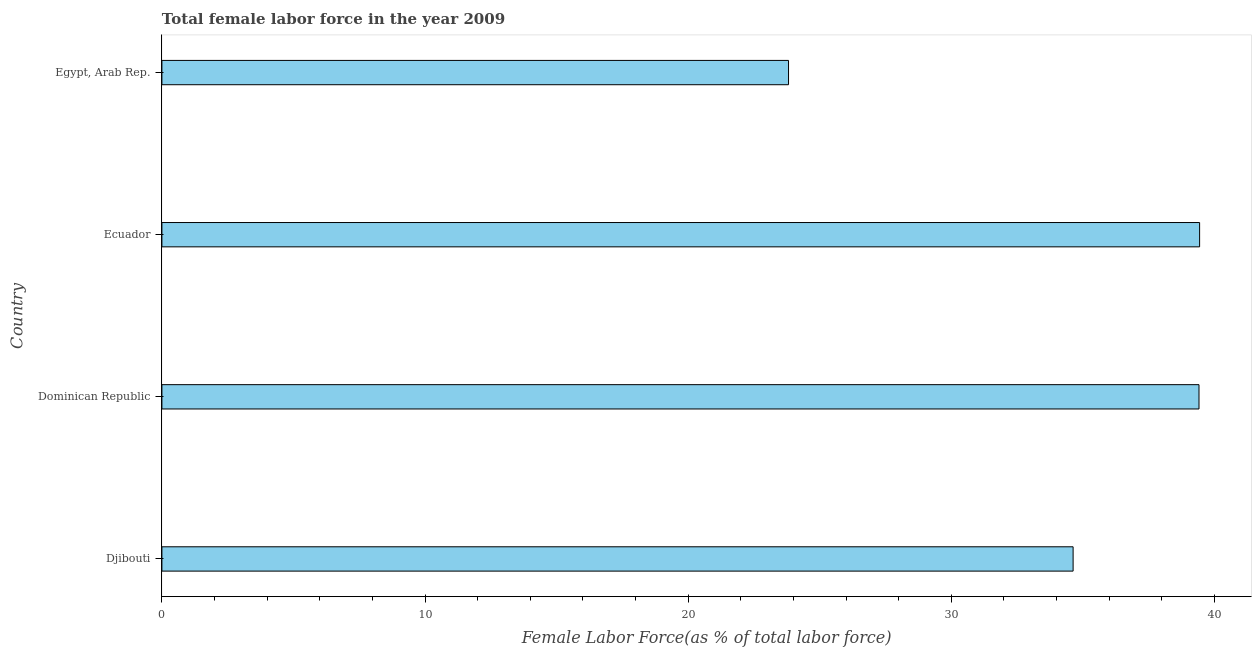Does the graph contain any zero values?
Your response must be concise. No. Does the graph contain grids?
Keep it short and to the point. No. What is the title of the graph?
Ensure brevity in your answer.  Total female labor force in the year 2009. What is the label or title of the X-axis?
Your response must be concise. Female Labor Force(as % of total labor force). What is the total female labor force in Ecuador?
Provide a short and direct response. 39.43. Across all countries, what is the maximum total female labor force?
Your answer should be compact. 39.43. Across all countries, what is the minimum total female labor force?
Your answer should be compact. 23.81. In which country was the total female labor force maximum?
Give a very brief answer. Ecuador. In which country was the total female labor force minimum?
Your answer should be very brief. Egypt, Arab Rep. What is the sum of the total female labor force?
Make the answer very short. 137.29. What is the difference between the total female labor force in Ecuador and Egypt, Arab Rep.?
Your response must be concise. 15.62. What is the average total female labor force per country?
Offer a very short reply. 34.32. What is the median total female labor force?
Give a very brief answer. 37.02. Is the total female labor force in Dominican Republic less than that in Ecuador?
Ensure brevity in your answer.  Yes. Is the difference between the total female labor force in Dominican Republic and Egypt, Arab Rep. greater than the difference between any two countries?
Keep it short and to the point. No. What is the difference between the highest and the second highest total female labor force?
Provide a short and direct response. 0.02. What is the difference between the highest and the lowest total female labor force?
Keep it short and to the point. 15.62. In how many countries, is the total female labor force greater than the average total female labor force taken over all countries?
Your answer should be very brief. 3. How many countries are there in the graph?
Provide a short and direct response. 4. What is the difference between two consecutive major ticks on the X-axis?
Your answer should be compact. 10. Are the values on the major ticks of X-axis written in scientific E-notation?
Your answer should be very brief. No. What is the Female Labor Force(as % of total labor force) in Djibouti?
Provide a short and direct response. 34.63. What is the Female Labor Force(as % of total labor force) in Dominican Republic?
Provide a short and direct response. 39.41. What is the Female Labor Force(as % of total labor force) of Ecuador?
Your answer should be compact. 39.43. What is the Female Labor Force(as % of total labor force) in Egypt, Arab Rep.?
Your answer should be compact. 23.81. What is the difference between the Female Labor Force(as % of total labor force) in Djibouti and Dominican Republic?
Offer a terse response. -4.78. What is the difference between the Female Labor Force(as % of total labor force) in Djibouti and Ecuador?
Offer a terse response. -4.81. What is the difference between the Female Labor Force(as % of total labor force) in Djibouti and Egypt, Arab Rep.?
Your answer should be compact. 10.81. What is the difference between the Female Labor Force(as % of total labor force) in Dominican Republic and Ecuador?
Provide a short and direct response. -0.02. What is the difference between the Female Labor Force(as % of total labor force) in Dominican Republic and Egypt, Arab Rep.?
Your response must be concise. 15.6. What is the difference between the Female Labor Force(as % of total labor force) in Ecuador and Egypt, Arab Rep.?
Offer a terse response. 15.62. What is the ratio of the Female Labor Force(as % of total labor force) in Djibouti to that in Dominican Republic?
Ensure brevity in your answer.  0.88. What is the ratio of the Female Labor Force(as % of total labor force) in Djibouti to that in Ecuador?
Your answer should be very brief. 0.88. What is the ratio of the Female Labor Force(as % of total labor force) in Djibouti to that in Egypt, Arab Rep.?
Your answer should be very brief. 1.45. What is the ratio of the Female Labor Force(as % of total labor force) in Dominican Republic to that in Ecuador?
Provide a succinct answer. 1. What is the ratio of the Female Labor Force(as % of total labor force) in Dominican Republic to that in Egypt, Arab Rep.?
Provide a short and direct response. 1.66. What is the ratio of the Female Labor Force(as % of total labor force) in Ecuador to that in Egypt, Arab Rep.?
Make the answer very short. 1.66. 